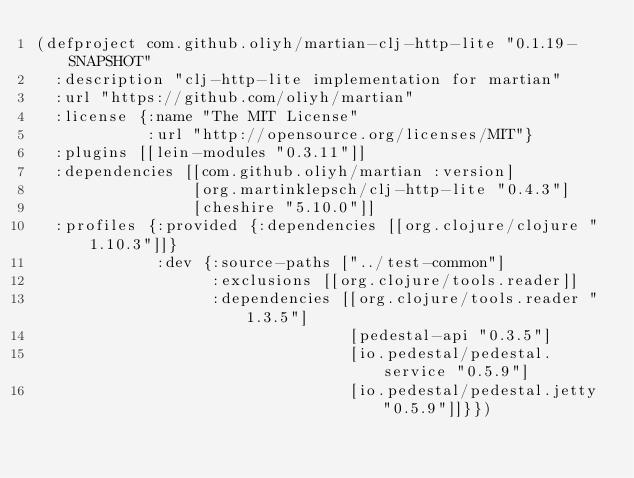<code> <loc_0><loc_0><loc_500><loc_500><_Clojure_>(defproject com.github.oliyh/martian-clj-http-lite "0.1.19-SNAPSHOT"
  :description "clj-http-lite implementation for martian"
  :url "https://github.com/oliyh/martian"
  :license {:name "The MIT License"
            :url "http://opensource.org/licenses/MIT"}
  :plugins [[lein-modules "0.3.11"]]
  :dependencies [[com.github.oliyh/martian :version]
                 [org.martinklepsch/clj-http-lite "0.4.3"]
                 [cheshire "5.10.0"]]
  :profiles {:provided {:dependencies [[org.clojure/clojure "1.10.3"]]}
             :dev {:source-paths ["../test-common"]
                   :exclusions [[org.clojure/tools.reader]]
                   :dependencies [[org.clojure/tools.reader "1.3.5"]
                                  [pedestal-api "0.3.5"]
                                  [io.pedestal/pedestal.service "0.5.9"]
                                  [io.pedestal/pedestal.jetty "0.5.9"]]}})
</code> 